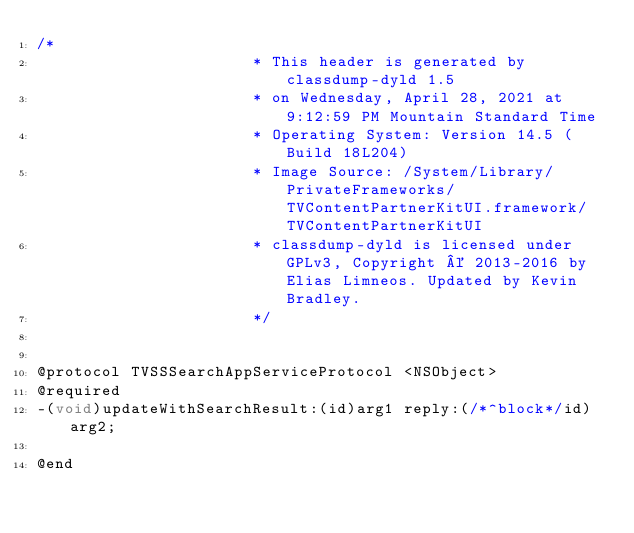Convert code to text. <code><loc_0><loc_0><loc_500><loc_500><_C_>/*
                       * This header is generated by classdump-dyld 1.5
                       * on Wednesday, April 28, 2021 at 9:12:59 PM Mountain Standard Time
                       * Operating System: Version 14.5 (Build 18L204)
                       * Image Source: /System/Library/PrivateFrameworks/TVContentPartnerKitUI.framework/TVContentPartnerKitUI
                       * classdump-dyld is licensed under GPLv3, Copyright © 2013-2016 by Elias Limneos. Updated by Kevin Bradley.
                       */


@protocol TVSSSearchAppServiceProtocol <NSObject>
@required
-(void)updateWithSearchResult:(id)arg1 reply:(/*^block*/id)arg2;

@end

</code> 